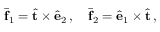<formula> <loc_0><loc_0><loc_500><loc_500>\bar { f } _ { 1 } = \hat { t } \times \hat { e } _ { 2 } \, , \quad \bar { f } _ { 2 } = \hat { e } _ { 1 } \times \hat { t } \, ,</formula> 